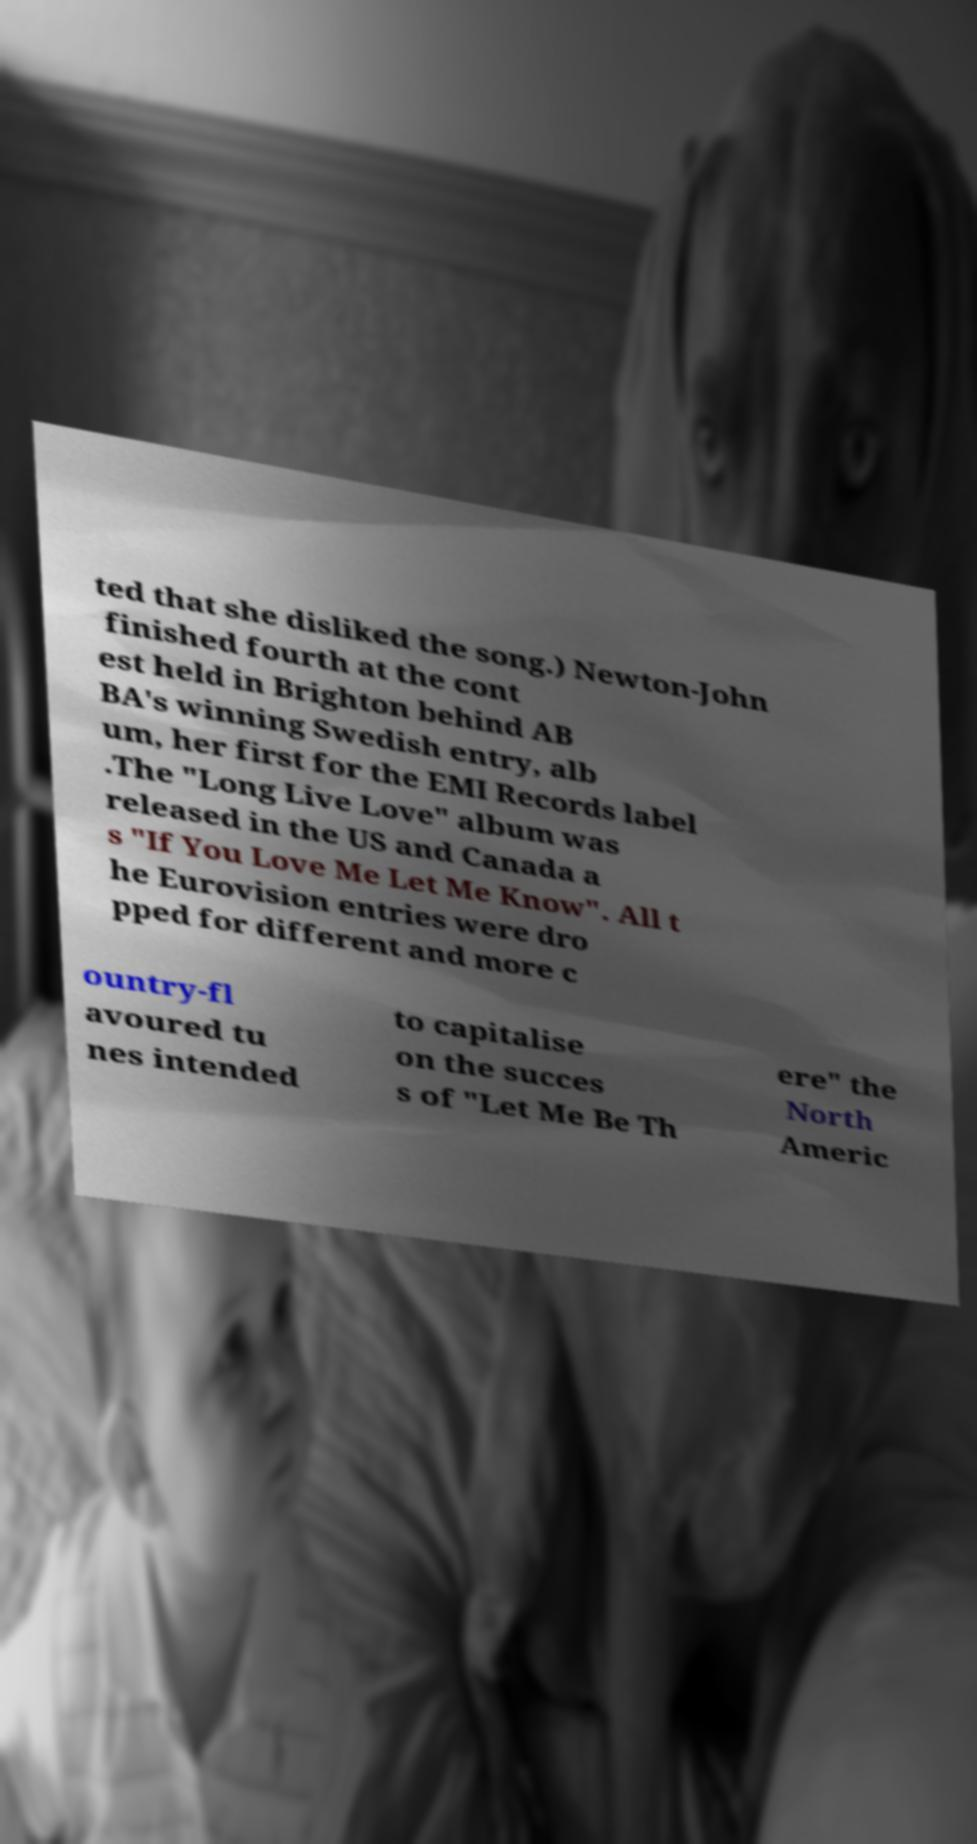I need the written content from this picture converted into text. Can you do that? ted that she disliked the song.) Newton-John finished fourth at the cont est held in Brighton behind AB BA's winning Swedish entry, alb um, her first for the EMI Records label .The "Long Live Love" album was released in the US and Canada a s "If You Love Me Let Me Know". All t he Eurovision entries were dro pped for different and more c ountry-fl avoured tu nes intended to capitalise on the succes s of "Let Me Be Th ere" the North Americ 